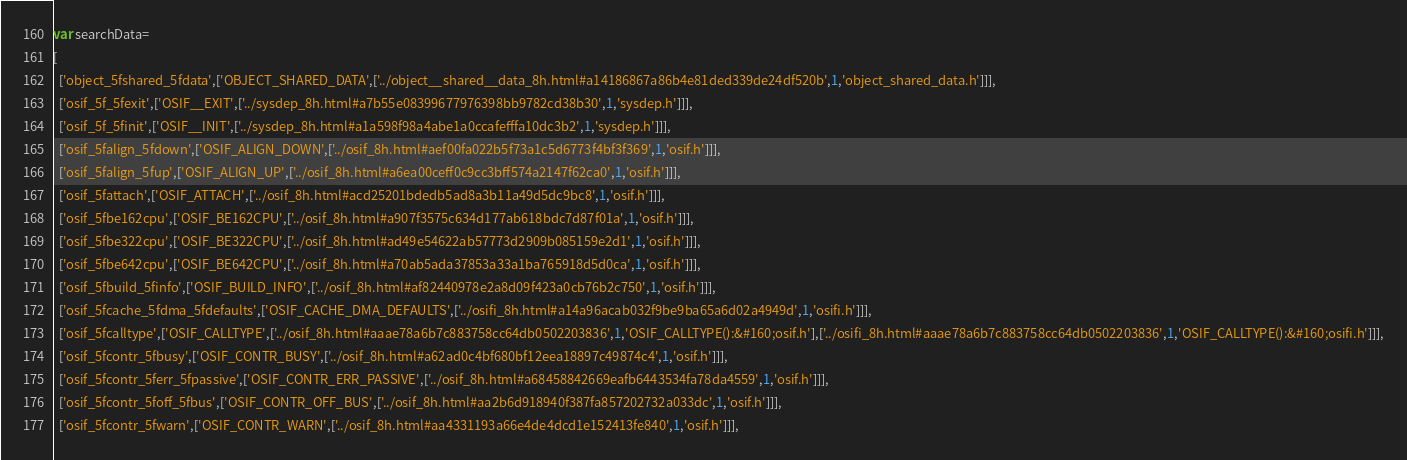Convert code to text. <code><loc_0><loc_0><loc_500><loc_500><_JavaScript_>var searchData=
[
  ['object_5fshared_5fdata',['OBJECT_SHARED_DATA',['../object__shared__data_8h.html#a14186867a86b4e81ded339de24df520b',1,'object_shared_data.h']]],
  ['osif_5f_5fexit',['OSIF__EXIT',['../sysdep_8h.html#a7b55e08399677976398bb9782cd38b30',1,'sysdep.h']]],
  ['osif_5f_5finit',['OSIF__INIT',['../sysdep_8h.html#a1a598f98a4abe1a0ccafefffa10dc3b2',1,'sysdep.h']]],
  ['osif_5falign_5fdown',['OSIF_ALIGN_DOWN',['../osif_8h.html#aef00fa022b5f73a1c5d6773f4bf3f369',1,'osif.h']]],
  ['osif_5falign_5fup',['OSIF_ALIGN_UP',['../osif_8h.html#a6ea00ceff0c9cc3bff574a2147f62ca0',1,'osif.h']]],
  ['osif_5fattach',['OSIF_ATTACH',['../osif_8h.html#acd25201bdedb5ad8a3b11a49d5dc9bc8',1,'osif.h']]],
  ['osif_5fbe162cpu',['OSIF_BE162CPU',['../osif_8h.html#a907f3575c634d177ab618bdc7d87f01a',1,'osif.h']]],
  ['osif_5fbe322cpu',['OSIF_BE322CPU',['../osif_8h.html#ad49e54622ab57773d2909b085159e2d1',1,'osif.h']]],
  ['osif_5fbe642cpu',['OSIF_BE642CPU',['../osif_8h.html#a70ab5ada37853a33a1ba765918d5d0ca',1,'osif.h']]],
  ['osif_5fbuild_5finfo',['OSIF_BUILD_INFO',['../osif_8h.html#af82440978e2a8d09f423a0cb76b2c750',1,'osif.h']]],
  ['osif_5fcache_5fdma_5fdefaults',['OSIF_CACHE_DMA_DEFAULTS',['../osifi_8h.html#a14a96acab032f9be9ba65a6d02a4949d',1,'osifi.h']]],
  ['osif_5fcalltype',['OSIF_CALLTYPE',['../osif_8h.html#aaae78a6b7c883758cc64db0502203836',1,'OSIF_CALLTYPE():&#160;osif.h'],['../osifi_8h.html#aaae78a6b7c883758cc64db0502203836',1,'OSIF_CALLTYPE():&#160;osifi.h']]],
  ['osif_5fcontr_5fbusy',['OSIF_CONTR_BUSY',['../osif_8h.html#a62ad0c4bf680bf12eea18897c49874c4',1,'osif.h']]],
  ['osif_5fcontr_5ferr_5fpassive',['OSIF_CONTR_ERR_PASSIVE',['../osif_8h.html#a68458842669eafb6443534fa78da4559',1,'osif.h']]],
  ['osif_5fcontr_5foff_5fbus',['OSIF_CONTR_OFF_BUS',['../osif_8h.html#aa2b6d918940f387fa857202732a033dc',1,'osif.h']]],
  ['osif_5fcontr_5fwarn',['OSIF_CONTR_WARN',['../osif_8h.html#aa4331193a66e4de4dcd1e152413fe840',1,'osif.h']]],</code> 